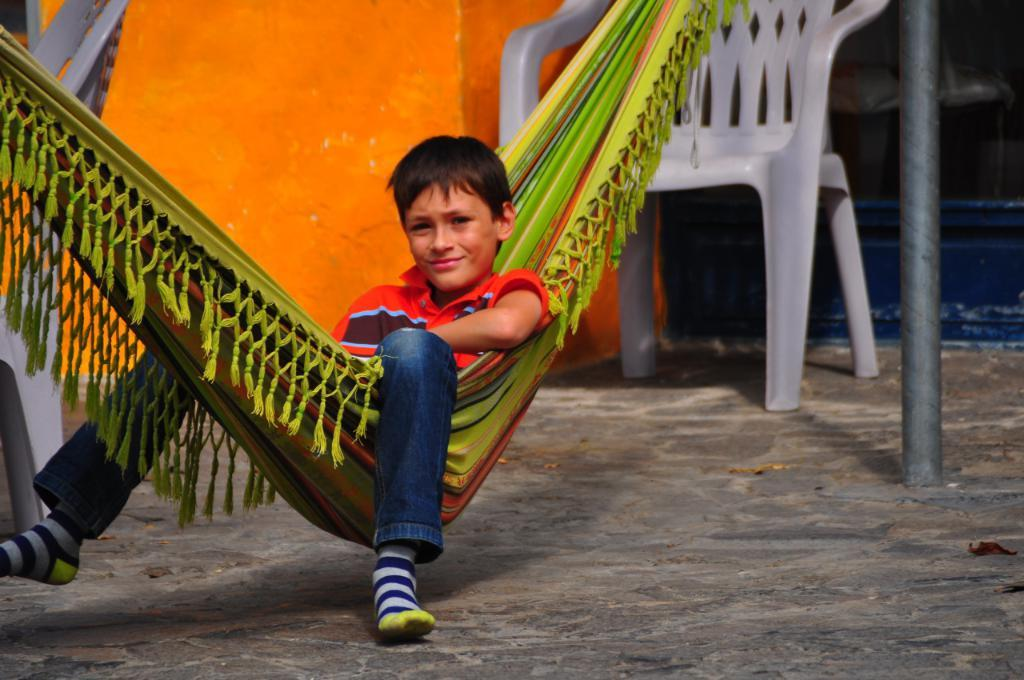Who is the main subject in the image? There is a boy in the image. What is the boy doing in the image? The boy is sitting on a cloth swing. What can be seen in the background of the image? There is a wall and a chair in the background of the image. What object is supporting the swing in the image? There is a pole in the image. What type of popcorn is the boy holding in the image? There is no popcorn present in the image; the boy is sitting on a cloth swing. What is the boy's opinion on the current political climate in the image? The image does not provide any information about the boy's opinion on the current political climate, as it focuses on the boy sitting on a cloth swing and the surrounding environment. 